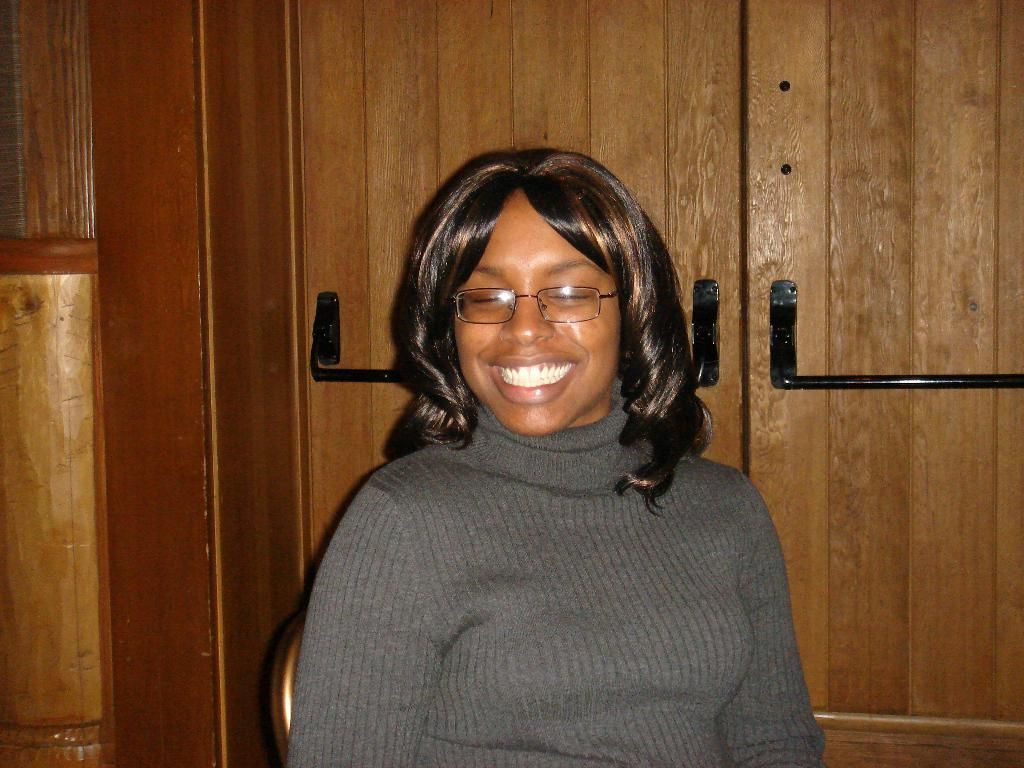Who is the main subject in the image? There is a woman in the image. What is the woman wearing? The woman is wearing a t-shirt. What is the woman doing in the image? The woman is sitting on a chair, smiling, and giving a pose for the picture. What can be seen in the background of the image? There is a cupboard visible in the background of the image. What is the rate of the lift in the image? There is no lift present in the image, so it is not possible to determine the rate. 